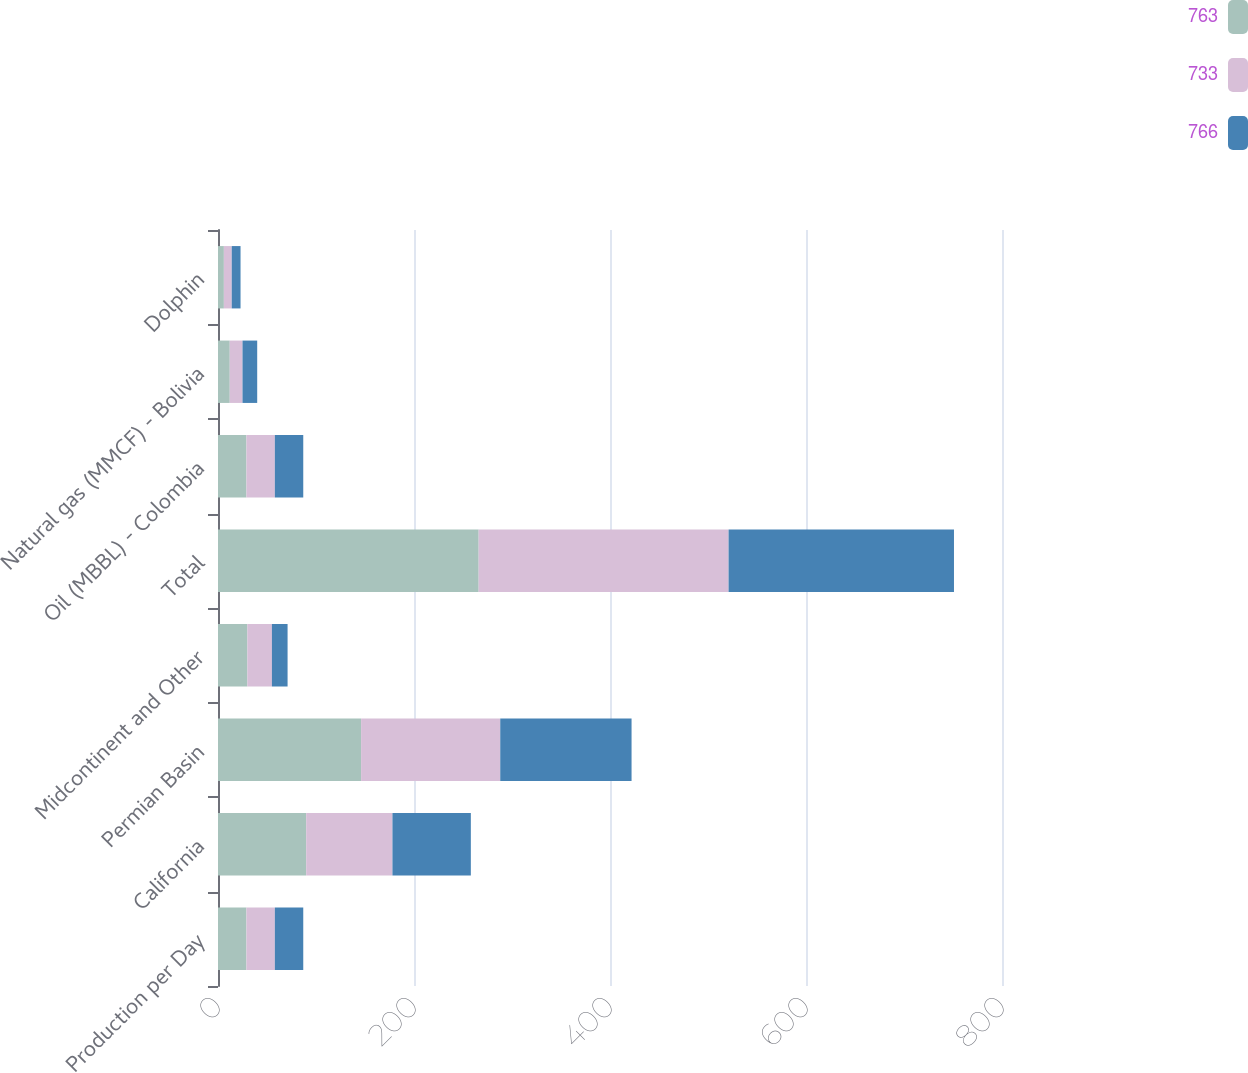<chart> <loc_0><loc_0><loc_500><loc_500><stacked_bar_chart><ecel><fcel>Production per Day<fcel>California<fcel>Permian Basin<fcel>Midcontinent and Other<fcel>Total<fcel>Oil (MBBL) - Colombia<fcel>Natural gas (MMCF) - Bolivia<fcel>Dolphin<nl><fcel>763<fcel>29<fcel>90<fcel>146<fcel>30<fcel>266<fcel>29<fcel>12<fcel>6<nl><fcel>733<fcel>29<fcel>88<fcel>142<fcel>25<fcel>255<fcel>29<fcel>13<fcel>8<nl><fcel>766<fcel>29<fcel>80<fcel>134<fcel>16<fcel>230<fcel>29<fcel>15<fcel>9<nl></chart> 